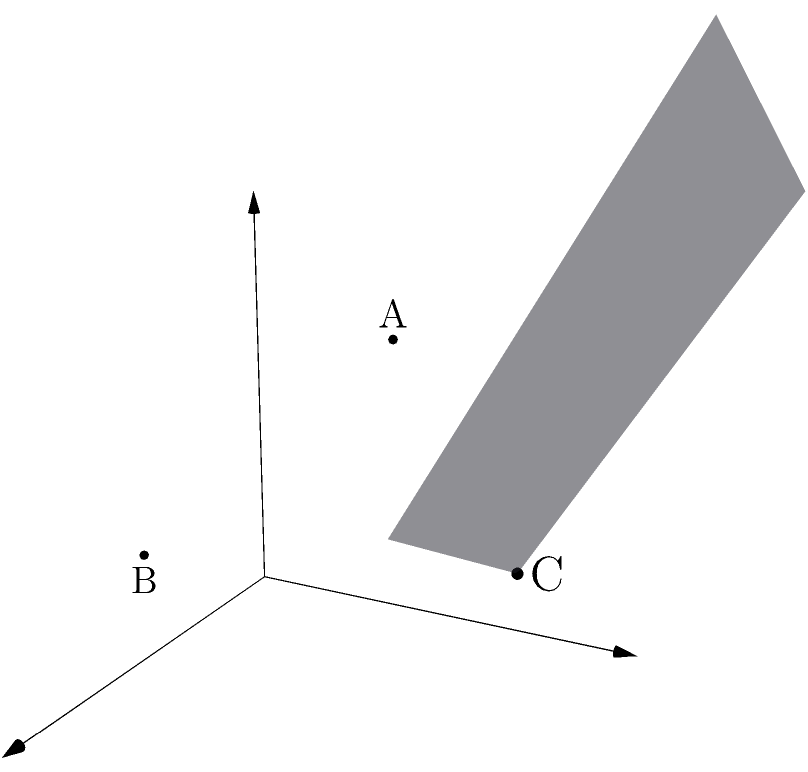Given three non-collinear points $A(1,2,3)$, $B(2,0,1)$, and $C(3,4,2)$ in 3D space, determine the equation of the plane passing through these points. Express your answer in the general form $ax + by + cz + d = 0$, where $a$, $b$, $c$, and $d$ are integers, and $a$ is positive. To find the equation of a plane given three non-collinear points, we can follow these steps:

1) First, we need to find two vectors on the plane. We can do this by subtracting the coordinates of two points from the third:

   $\vec{AB} = B - A = (2,0,1) - (1,2,3) = (1,-2,-2)$
   $\vec{AC} = C - A = (3,4,2) - (1,2,3) = (2,2,-1)$

2) The normal vector to the plane is the cross product of these two vectors:

   $\vec{n} = \vec{AB} \times \vec{AC} = \begin{vmatrix} 
   i & j & k \\
   1 & -2 & -2 \\
   2 & 2 & -1
   \end{vmatrix} = (-2)i + (-3)j + (6)k = (-2,-3,6)$

3) The equation of a plane is $ax + by + cz + d = 0$, where $(a,b,c)$ is the normal vector. So our equation is:

   $-2x - 3y + 6z + d = 0$

4) To find $d$, we can substitute the coordinates of any of the given points. Let's use $A(1,2,3)$:

   $-2(1) - 3(2) + 6(3) + d = 0$
   $-2 - 6 + 18 + d = 0$
   $10 + d = 0$
   $d = -10$

5) Therefore, the equation of the plane is:

   $-2x - 3y + 6z - 10 = 0$

6) To make $a$ positive, we multiply everything by -1:

   $2x + 3y - 6z + 10 = 0$

This is the final equation of the plane in the required form.
Answer: $2x + 3y - 6z + 10 = 0$ 